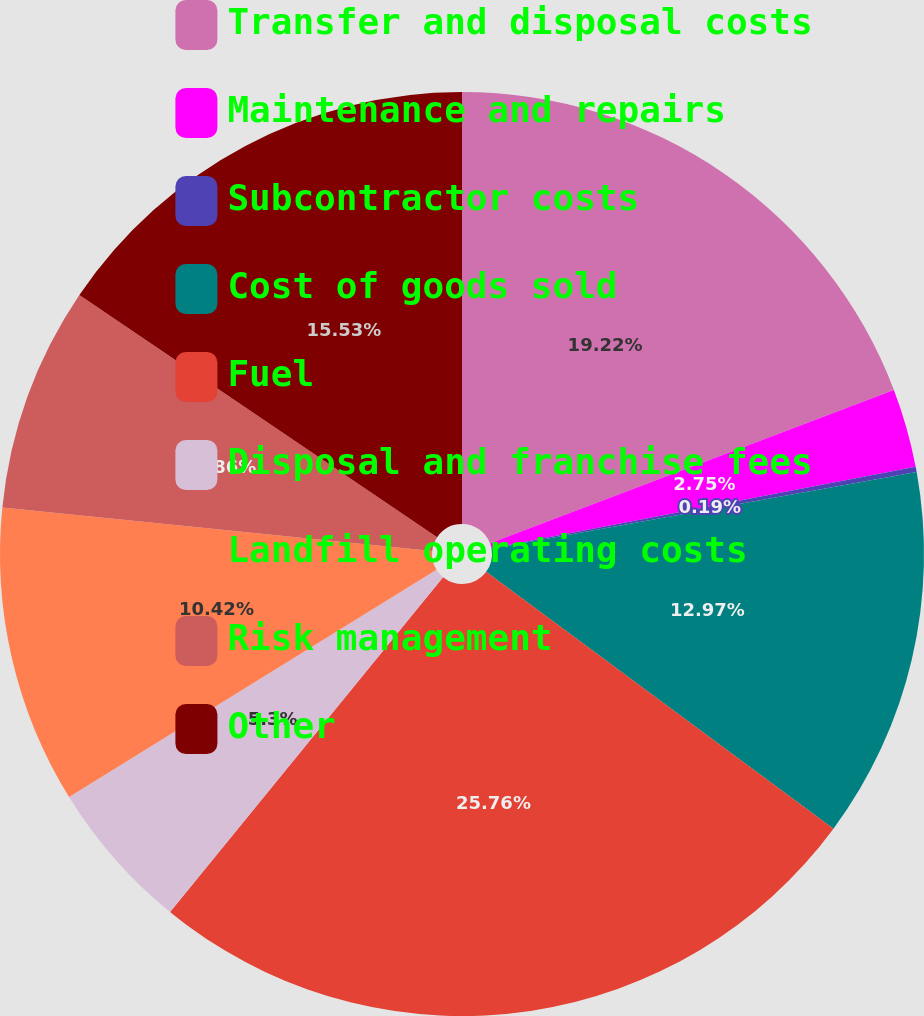<chart> <loc_0><loc_0><loc_500><loc_500><pie_chart><fcel>Transfer and disposal costs<fcel>Maintenance and repairs<fcel>Subcontractor costs<fcel>Cost of goods sold<fcel>Fuel<fcel>Disposal and franchise fees<fcel>Landfill operating costs<fcel>Risk management<fcel>Other<nl><fcel>19.22%<fcel>2.75%<fcel>0.19%<fcel>12.97%<fcel>25.75%<fcel>5.3%<fcel>10.42%<fcel>7.86%<fcel>15.53%<nl></chart> 